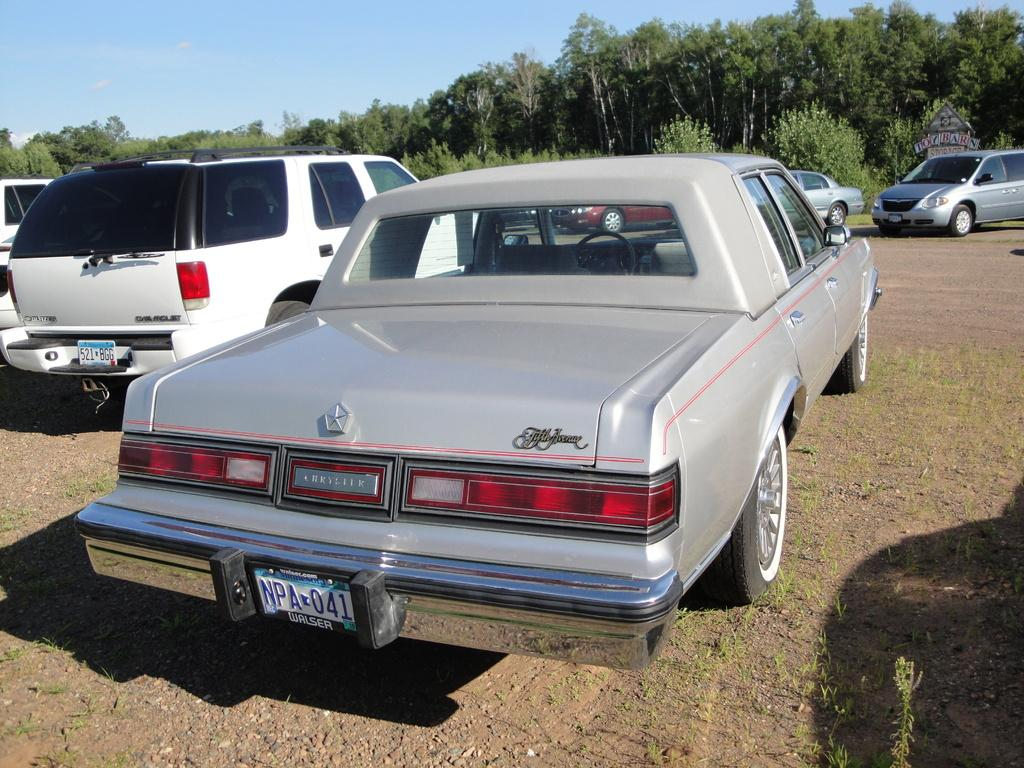What type of vehicles are on the ground in the image? There are cars on the ground in the image. What is located on the right side of the image? There is a board on the right side of the image. What can be seen in the background of the image? There are trees and the sky visible in the background of the image. What type of suit is being worn by the grain in the image? There is no grain or suit present in the image. 